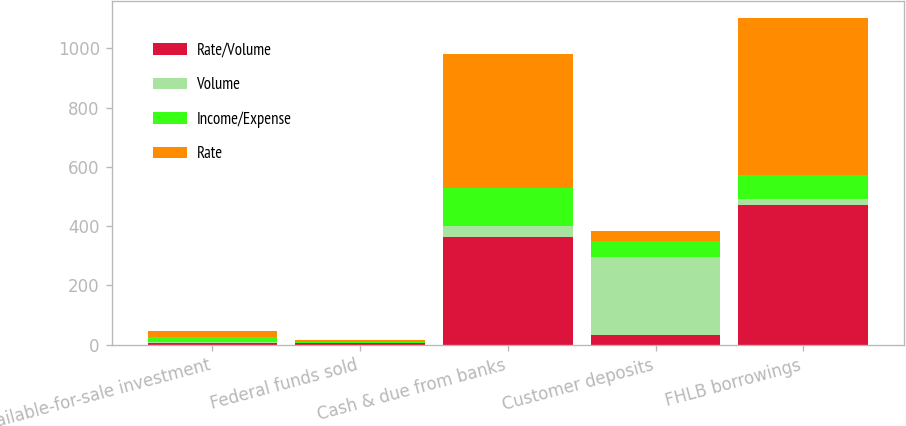Convert chart to OTSL. <chart><loc_0><loc_0><loc_500><loc_500><stacked_bar_chart><ecel><fcel>Available-for-sale investment<fcel>Federal funds sold<fcel>Cash & due from banks<fcel>Customer deposits<fcel>FHLB borrowings<nl><fcel>Rate/Volume<fcel>7<fcel>6<fcel>362<fcel>31<fcel>471<nl><fcel>Volume<fcel>2<fcel>1<fcel>40<fcel>264<fcel>22<nl><fcel>Income/Expense<fcel>16<fcel>1<fcel>128<fcel>56<fcel>81<nl><fcel>Rate<fcel>21<fcel>6<fcel>450<fcel>31<fcel>530<nl></chart> 